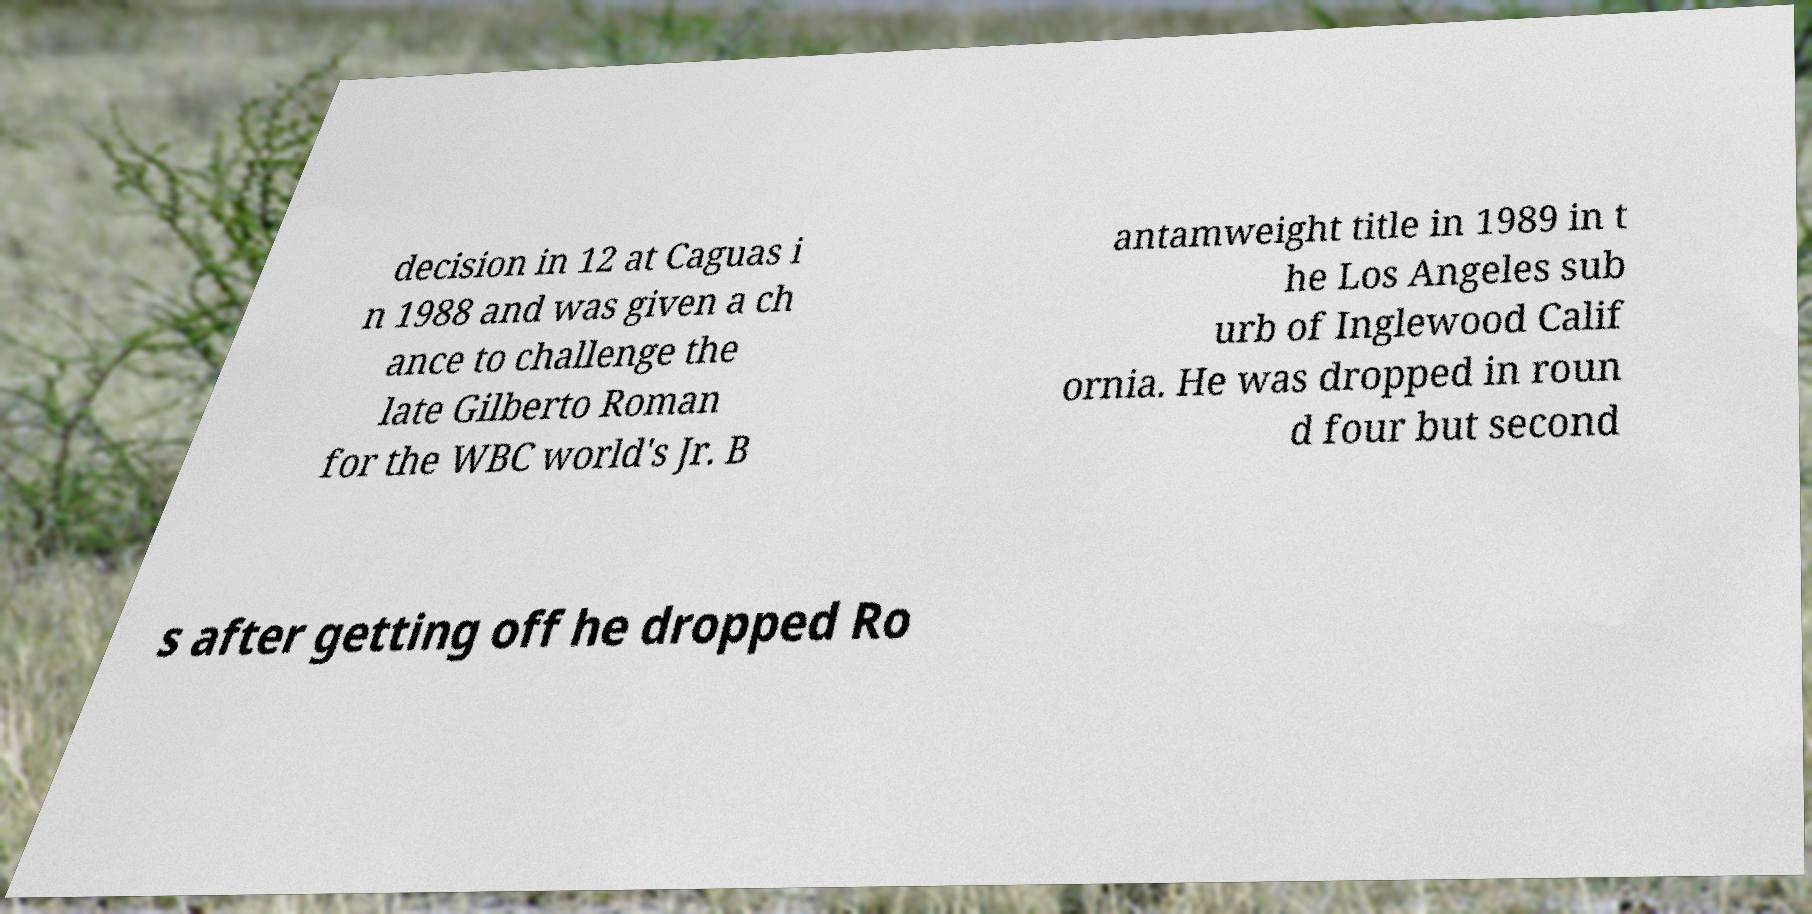Can you read and provide the text displayed in the image?This photo seems to have some interesting text. Can you extract and type it out for me? decision in 12 at Caguas i n 1988 and was given a ch ance to challenge the late Gilberto Roman for the WBC world's Jr. B antamweight title in 1989 in t he Los Angeles sub urb of Inglewood Calif ornia. He was dropped in roun d four but second s after getting off he dropped Ro 